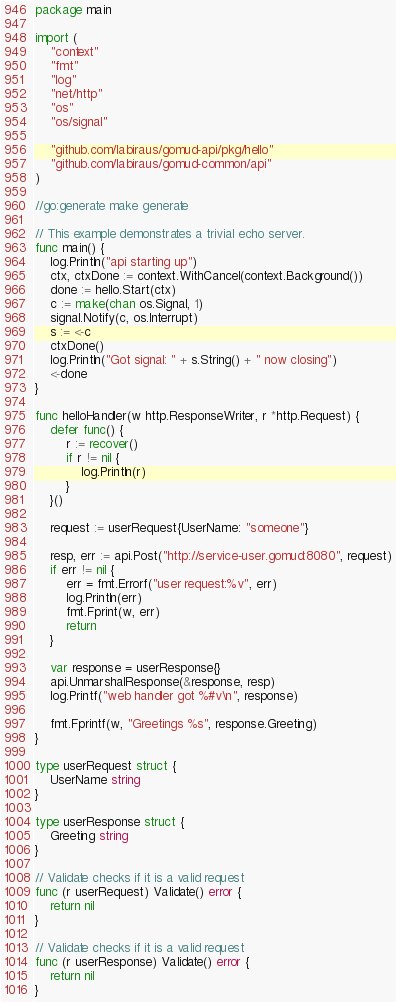Convert code to text. <code><loc_0><loc_0><loc_500><loc_500><_Go_>package main

import (
	"context"
	"fmt"
	"log"
	"net/http"
	"os"
	"os/signal"

	"github.com/labiraus/gomud-api/pkg/hello"
	"github.com/labiraus/gomud-common/api"
)

//go:generate make generate

// This example demonstrates a trivial echo server.
func main() {
	log.Println("api starting up")
	ctx, ctxDone := context.WithCancel(context.Background())
	done := hello.Start(ctx)
	c := make(chan os.Signal, 1)
	signal.Notify(c, os.Interrupt)
	s := <-c
	ctxDone()
	log.Println("Got signal: " + s.String() + " now closing")
	<-done
}

func helloHandler(w http.ResponseWriter, r *http.Request) {
	defer func() {
		r := recover()
		if r != nil {
			log.Println(r)
		}
	}()

	request := userRequest{UserName: "someone"}

	resp, err := api.Post("http://service-user.gomud:8080", request)
	if err != nil {
		err = fmt.Errorf("user request:%v", err)
		log.Println(err)
		fmt.Fprint(w, err)
		return
	}

	var response = userResponse{}
	api.UnmarshalResponse(&response, resp)
	log.Printf("web handler got %#v\n", response)

	fmt.Fprintf(w, "Greetings %s", response.Greeting)
}

type userRequest struct {
	UserName string
}

type userResponse struct {
	Greeting string
}

// Validate checks if it is a valid request
func (r userRequest) Validate() error {
	return nil
}

// Validate checks if it is a valid request
func (r userResponse) Validate() error {
	return nil
}
</code> 